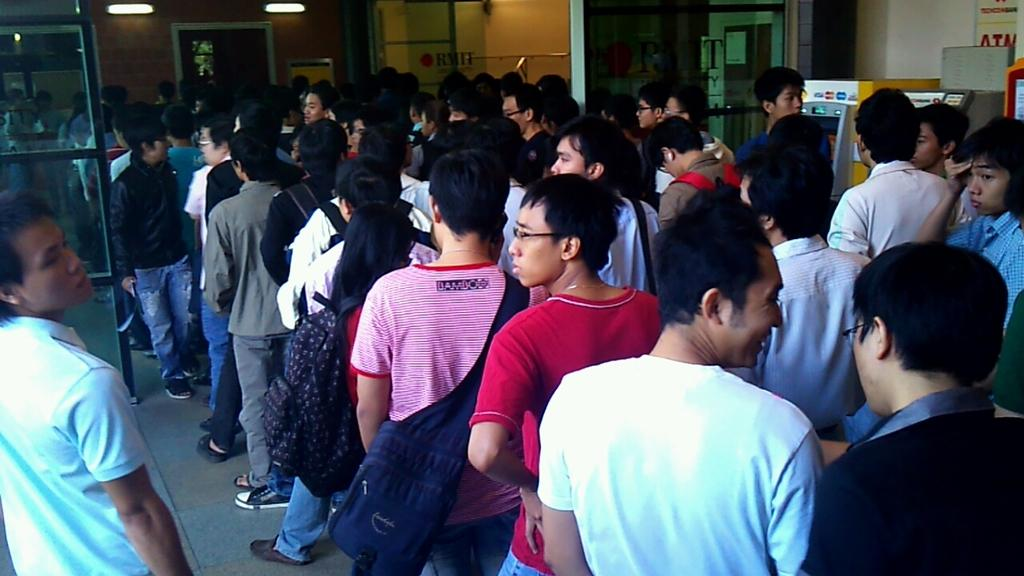What is the arrangement of the men in the image? The men are arranged in three rows in the image. What is located behind the men in the image? There is an ATM machine in the back of the image. What is the ATM machine positioned in front of? The ATM machine is in front of a wall. What can be seen above the men in the image? There are lights over the ceiling in the image. What type of ornament is being protested by the men in the image? There is no protest or ornament present in the image. The men are standing in lines, and the image does not suggest any protest or ornament-related activity. 